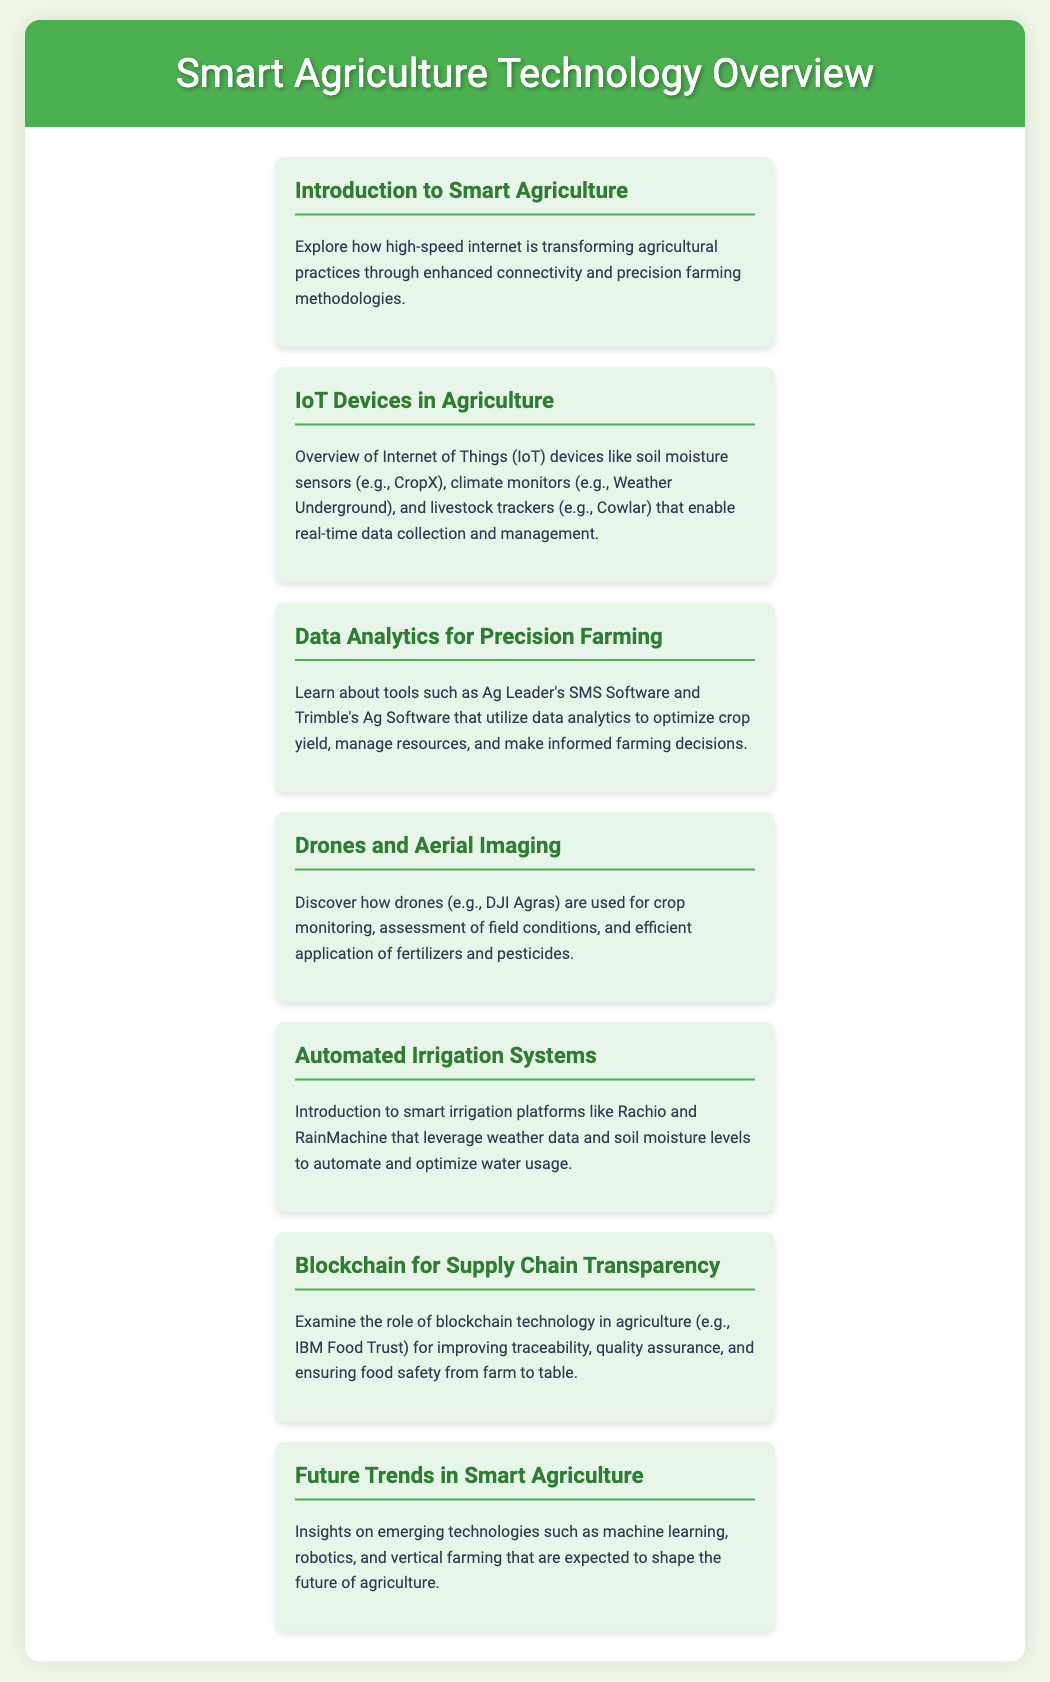what is the title of the document? The title of the document is prominently displayed in the header section of the document.
Answer: Smart Agriculture Technology Overview what is one application of IoT devices mentioned? The document lists specific IoT devices and their uses for real-time data collection.
Answer: soil moisture sensors which drone model is referenced for crop monitoring? The document mentions a specific drone model used for agricultural purposes.
Answer: DJI Agras what technology is discussed in relation to supply chain transparency? The document describes a technological approach to enhance agricultural supply chains.
Answer: blockchain name one automated irrigation system mentioned. The document provides examples of smart irrigation platforms to support optimized water use.
Answer: Rachio what is a tool used for data analytics in precision farming? The document highlights specific software dedicated to data analytics for agriculture.
Answer: Ag Leader's SMS Software how does high-speed internet benefit farming practices? The introduction discusses the impact of high-speed internet on modern agricultural practices.
Answer: enhanced connectivity what future technology trend is mentioned for agriculture? The document discusses emerging technologies that could influence agricultural methods in the future.
Answer: machine learning 